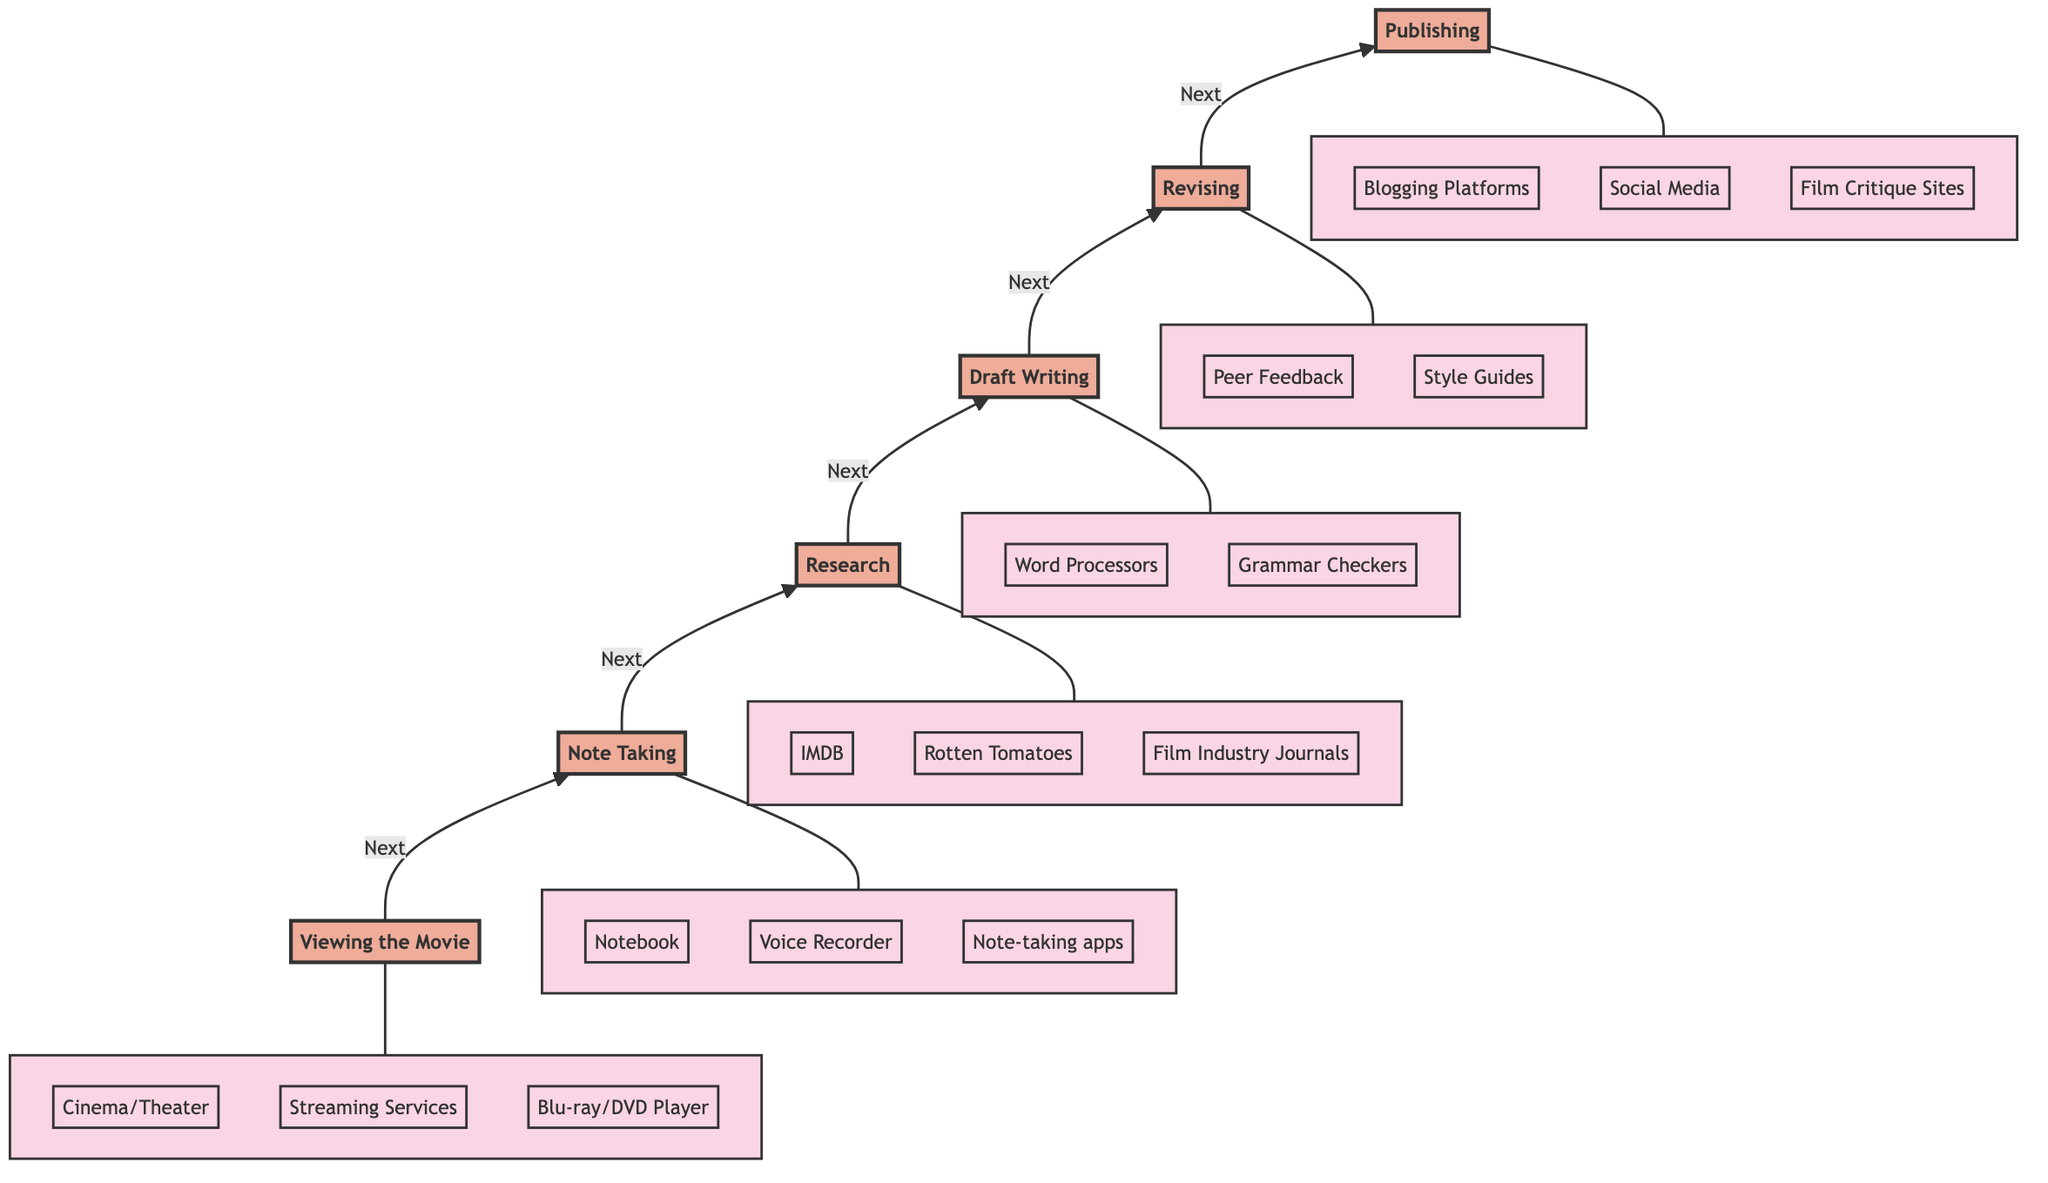What is the first stage in the film critique journey? The first stage is explicitly labeled as "1. Viewing the Movie" in the diagram, indicating it is the starting point of the process.
Answer: Viewing the Movie How many stages are there in the diagram? By counting each individual stage node from the top to the bottom of the flowchart, there are six distinct stages.
Answer: 6 What stage follows Note Taking? The arrow connecting the "Note Taking" stage leads directly to the "Research" stage, indicating that it is the next step in the journey.
Answer: Research Which tools are included in the Draft Writing stage? The subgraph for "Draft Writing" lists several specific tools, which include "Laptop/Computer," "Word Processors," and "Grammar Checkers."
Answer: Laptop/Computer, Word Processors, Grammar Checkers What is the final output of the flow chart process? The last stage in the chart is labeled "6. Publishing," indicating that the final output of the process is publishing the review.
Answer: Publishing Which stage involves peer feedback? The "Revising" stage specifically includes "Peer Feedback" as one of the tools utilized in refining the draft to improve quality.
Answer: Revising What is the relationship between Viewing the Movie and Note Taking? The flowchart shows a direct connection from "Viewing the Movie" to "Note Taking," demonstrating that note taking follows the viewing of the film.
Answer: Next What methods are used in the Research stage? The description under the "Research" stage mentions the methods used, such as “Look up background information,” “Read other critiques,” and “Understand cultural and production context.”
Answer: Look up background information, Read other critiques, Understand cultural and production context What is the main purpose of the Publishing stage? The "Publishing" stage topic specifies that it involves publishing the final review on various platforms, highlighting the aim of sharing completed critiques.
Answer: Publishing the final review 